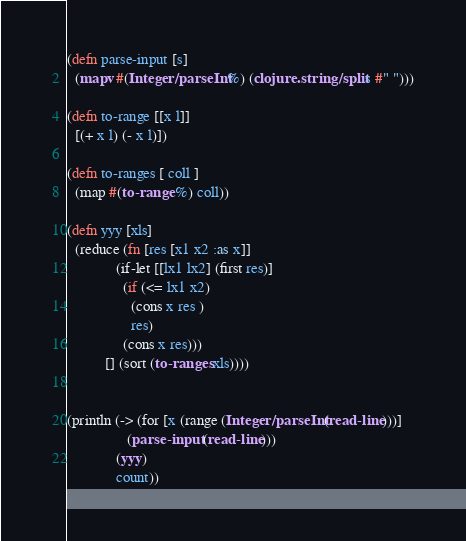Convert code to text. <code><loc_0><loc_0><loc_500><loc_500><_Clojure_>(defn parse-input [s]
  (mapv #(Integer/parseInt %) (clojure.string/split s #" ")))

(defn to-range [[x l]]
  [(+ x l) (- x l)])

(defn to-ranges [ coll ]
  (map #(to-range %) coll))

(defn yyy [xls]
  (reduce (fn [res [x1 x2 :as x]]
             (if-let [[lx1 lx2] (first res)]
               (if (<= lx1 x2)
                 (cons x res )
                 res)
               (cons x res)))
          [] (sort (to-ranges xls))))


(println (-> (for [x (range (Integer/parseInt (read-line)))]
			    (parse-input (read-line)))
             (yyy)
             count))</code> 